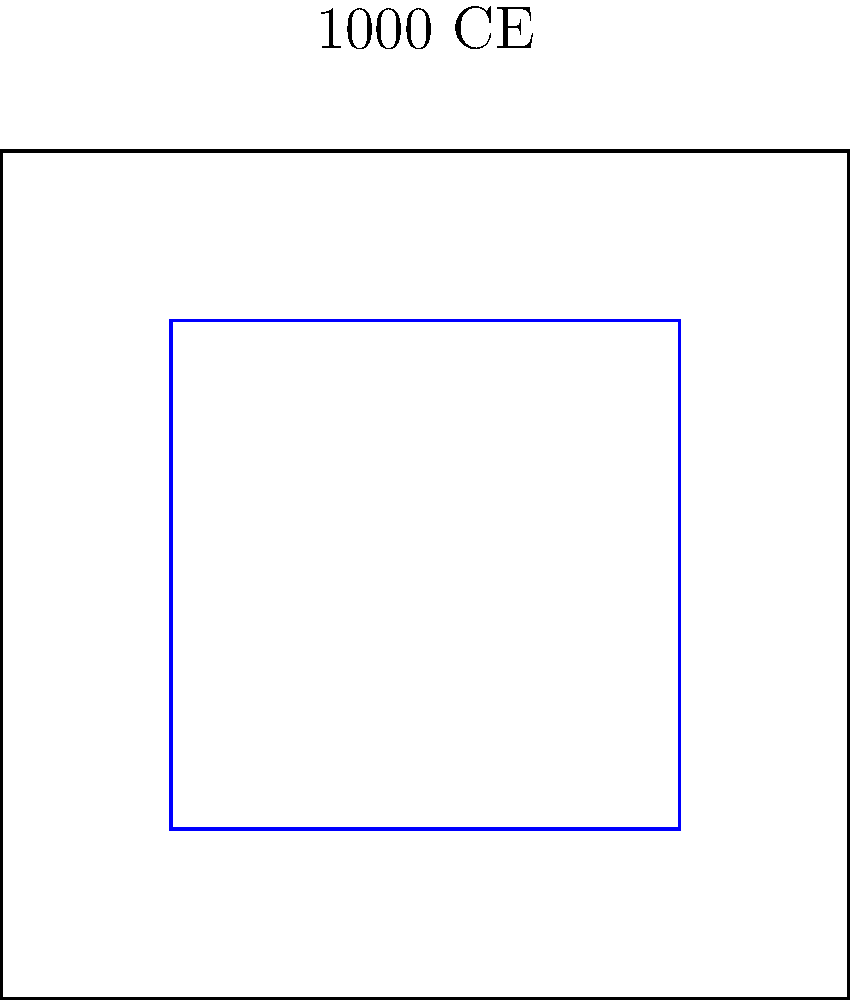Based on the series of maps showing the territorial changes of the Kingdom of Hungary during the medieval period, which century saw the greatest expansion of the kingdom's borders? To answer this question, we need to analyze the three maps provided, representing the Kingdom of Hungary at different points in medieval history:

1. 1000 CE: This map shows the initial Kingdom of Hungary, represented by the blue area. This serves as our baseline for comparison.

2. 1200 CE: The green area represents the kingdom's territory in 1200 CE. We can clearly see that the borders have expanded significantly compared to the 1000 CE map. The kingdom now covers a larger area within the given borders.

3. 1400 CE: The red area shows the kingdom's territory in 1400 CE. Compared to the 1200 CE map, we can observe that the territory has actually decreased in size.

By comparing these three maps, we can conclude that the greatest expansion occurred between 1000 CE and 1200 CE, which falls within the 12th century (1101-1200 CE).

The expansion during this period is likely due to the policies of kings such as Ladislaus I (1077-1095) and Coloman (1095-1116), who were known for their military conquests and territorial expansions, particularly in the Balkans and towards the Adriatic coast.

The subsequent reduction in territory by 1400 CE could be attributed to factors such as the Mongol invasion of 1241-1242, internal conflicts, or the rise of neighboring powers.
Answer: 12th century 